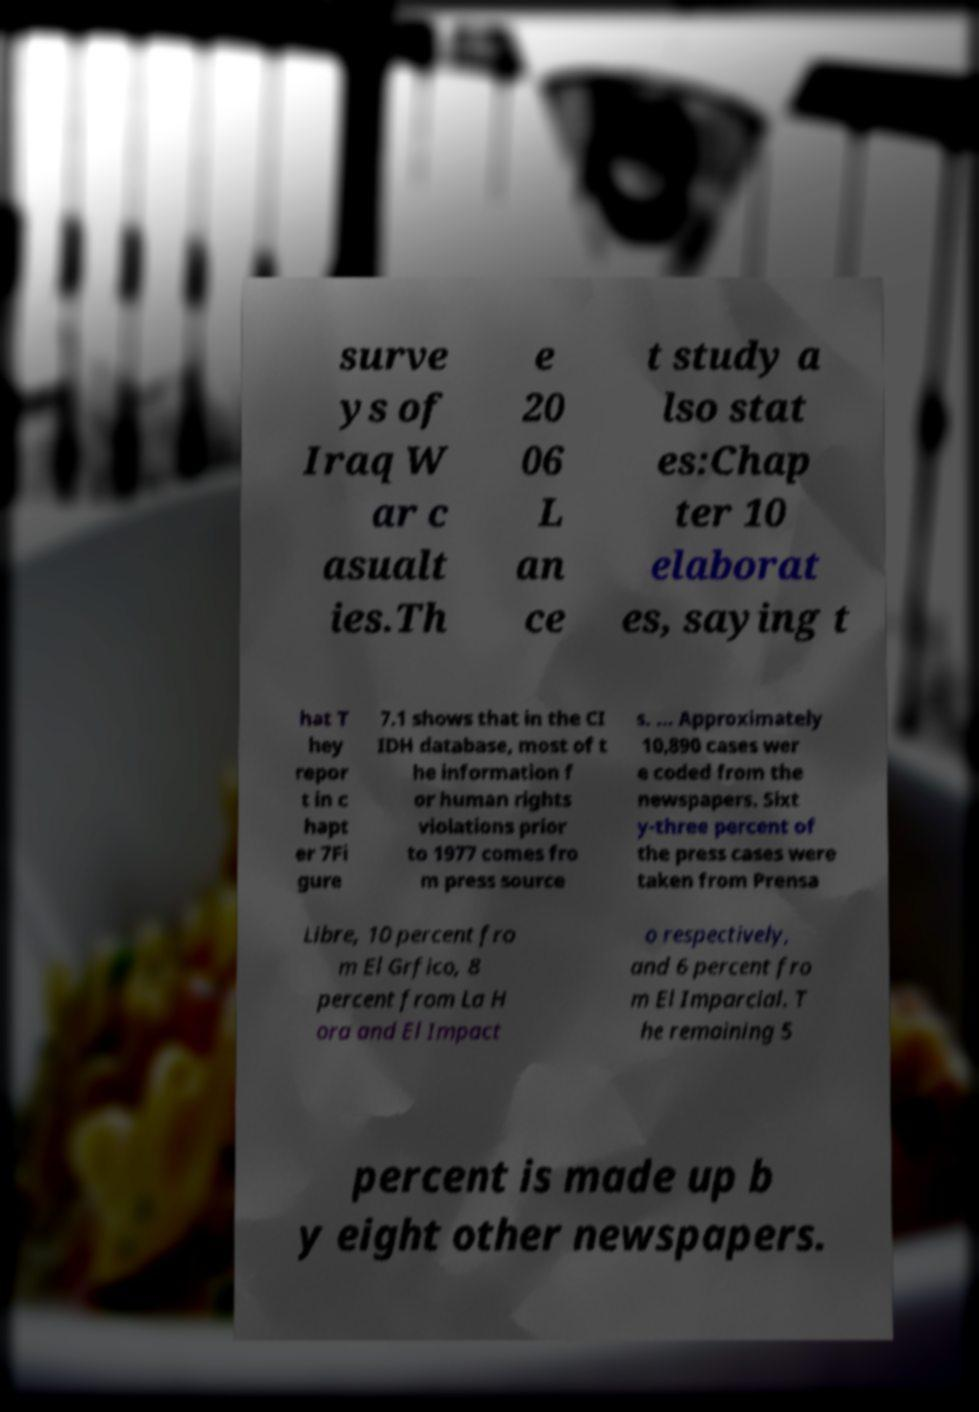Could you extract and type out the text from this image? surve ys of Iraq W ar c asualt ies.Th e 20 06 L an ce t study a lso stat es:Chap ter 10 elaborat es, saying t hat T hey repor t in c hapt er 7Fi gure 7.1 shows that in the CI IDH database, most of t he information f or human rights violations prior to 1977 comes fro m press source s. ... Approximately 10,890 cases wer e coded from the newspapers. Sixt y-three percent of the press cases were taken from Prensa Libre, 10 percent fro m El Grfico, 8 percent from La H ora and El Impact o respectively, and 6 percent fro m El Imparcial. T he remaining 5 percent is made up b y eight other newspapers. 